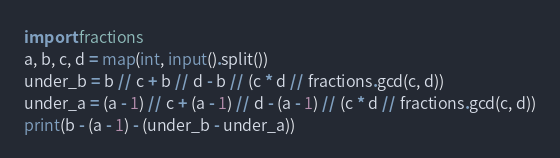Convert code to text. <code><loc_0><loc_0><loc_500><loc_500><_Python_>import fractions
a, b, c, d = map(int, input().split())
under_b = b // c + b // d - b // (c * d // fractions.gcd(c, d))
under_a = (a - 1) // c + (a - 1) // d - (a - 1) // (c * d // fractions.gcd(c, d))
print(b - (a - 1) - (under_b - under_a))</code> 